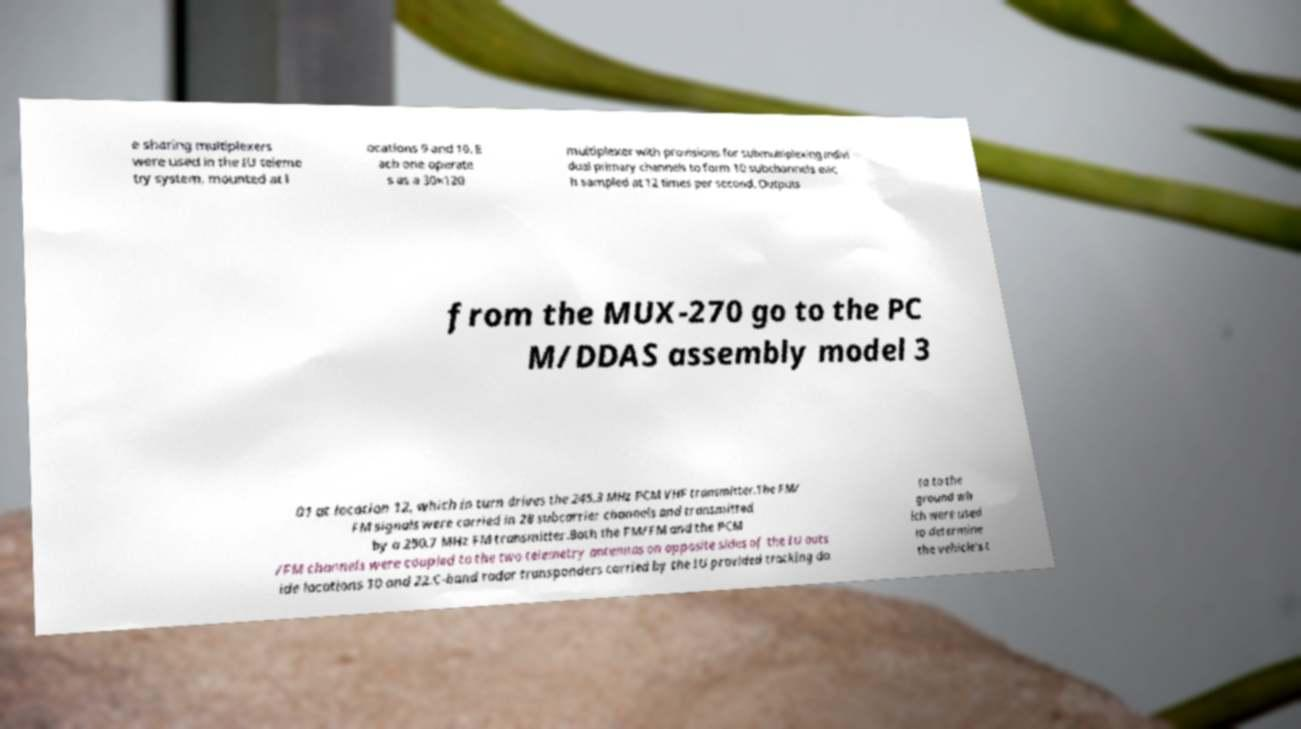There's text embedded in this image that I need extracted. Can you transcribe it verbatim? e sharing multiplexers were used in the IU teleme try system, mounted at l ocations 9 and 10. E ach one operate s as a 30×120 multiplexer with provisions for submultiplexing indivi dual primary channels to form 10 subchannels eac h sampled at 12 times per second. Outputs from the MUX-270 go to the PC M/DDAS assembly model 3 01 at location 12, which in turn drives the 245.3 MHz PCM VHF transmitter.The FM/ FM signals were carried in 28 subcarrier channels and transmitted by a 250.7 MHz FM transmitter.Both the FM/FM and the PCM /FM channels were coupled to the two telemetry antennas on opposite sides of the IU outs ide locations 10 and 22.C-band radar transponders carried by the IU provided tracking da ta to the ground wh ich were used to determine the vehicle's t 